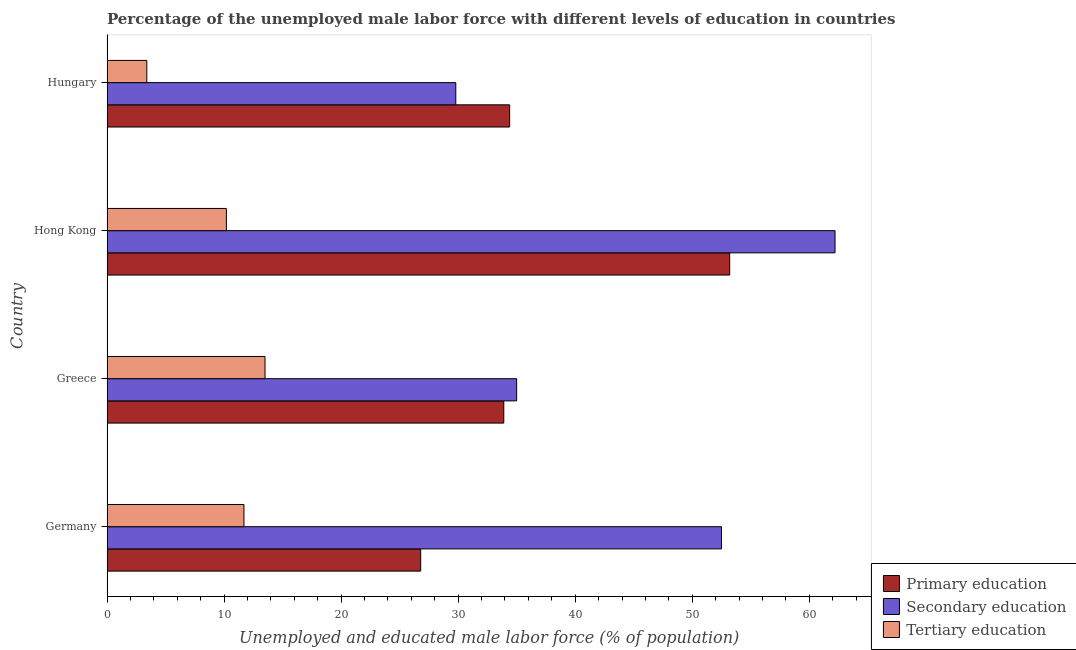How many groups of bars are there?
Your answer should be compact. 4. Are the number of bars on each tick of the Y-axis equal?
Your answer should be compact. Yes. How many bars are there on the 1st tick from the top?
Ensure brevity in your answer.  3. What is the label of the 2nd group of bars from the top?
Your answer should be compact. Hong Kong. In how many cases, is the number of bars for a given country not equal to the number of legend labels?
Keep it short and to the point. 0. What is the percentage of male labor force who received primary education in Germany?
Give a very brief answer. 26.8. Across all countries, what is the maximum percentage of male labor force who received secondary education?
Give a very brief answer. 62.2. Across all countries, what is the minimum percentage of male labor force who received secondary education?
Give a very brief answer. 29.8. In which country was the percentage of male labor force who received primary education maximum?
Make the answer very short. Hong Kong. In which country was the percentage of male labor force who received tertiary education minimum?
Your answer should be very brief. Hungary. What is the total percentage of male labor force who received primary education in the graph?
Your response must be concise. 148.3. What is the difference between the percentage of male labor force who received tertiary education in Germany and that in Hong Kong?
Keep it short and to the point. 1.5. What is the difference between the percentage of male labor force who received tertiary education in Hungary and the percentage of male labor force who received primary education in Hong Kong?
Provide a short and direct response. -49.8. What is the average percentage of male labor force who received tertiary education per country?
Offer a very short reply. 9.7. What is the difference between the percentage of male labor force who received tertiary education and percentage of male labor force who received primary education in Hong Kong?
Give a very brief answer. -43. In how many countries, is the percentage of male labor force who received tertiary education greater than 50 %?
Provide a succinct answer. 0. What is the ratio of the percentage of male labor force who received tertiary education in Germany to that in Greece?
Your answer should be very brief. 0.87. What is the difference between the highest and the second highest percentage of male labor force who received secondary education?
Provide a succinct answer. 9.7. What is the difference between the highest and the lowest percentage of male labor force who received tertiary education?
Offer a very short reply. 10.1. What does the 1st bar from the top in Greece represents?
Your answer should be very brief. Tertiary education. What does the 2nd bar from the bottom in Greece represents?
Offer a very short reply. Secondary education. Are all the bars in the graph horizontal?
Provide a short and direct response. Yes. Does the graph contain grids?
Keep it short and to the point. No. Where does the legend appear in the graph?
Ensure brevity in your answer.  Bottom right. How many legend labels are there?
Provide a succinct answer. 3. How are the legend labels stacked?
Give a very brief answer. Vertical. What is the title of the graph?
Provide a short and direct response. Percentage of the unemployed male labor force with different levels of education in countries. What is the label or title of the X-axis?
Provide a succinct answer. Unemployed and educated male labor force (% of population). What is the Unemployed and educated male labor force (% of population) of Primary education in Germany?
Your answer should be compact. 26.8. What is the Unemployed and educated male labor force (% of population) of Secondary education in Germany?
Provide a succinct answer. 52.5. What is the Unemployed and educated male labor force (% of population) of Tertiary education in Germany?
Provide a short and direct response. 11.7. What is the Unemployed and educated male labor force (% of population) in Primary education in Greece?
Your answer should be compact. 33.9. What is the Unemployed and educated male labor force (% of population) of Secondary education in Greece?
Provide a succinct answer. 35. What is the Unemployed and educated male labor force (% of population) of Primary education in Hong Kong?
Provide a short and direct response. 53.2. What is the Unemployed and educated male labor force (% of population) in Secondary education in Hong Kong?
Give a very brief answer. 62.2. What is the Unemployed and educated male labor force (% of population) of Tertiary education in Hong Kong?
Your answer should be compact. 10.2. What is the Unemployed and educated male labor force (% of population) of Primary education in Hungary?
Your response must be concise. 34.4. What is the Unemployed and educated male labor force (% of population) of Secondary education in Hungary?
Your answer should be compact. 29.8. What is the Unemployed and educated male labor force (% of population) of Tertiary education in Hungary?
Your answer should be very brief. 3.4. Across all countries, what is the maximum Unemployed and educated male labor force (% of population) of Primary education?
Provide a succinct answer. 53.2. Across all countries, what is the maximum Unemployed and educated male labor force (% of population) in Secondary education?
Provide a succinct answer. 62.2. Across all countries, what is the maximum Unemployed and educated male labor force (% of population) of Tertiary education?
Give a very brief answer. 13.5. Across all countries, what is the minimum Unemployed and educated male labor force (% of population) in Primary education?
Offer a terse response. 26.8. Across all countries, what is the minimum Unemployed and educated male labor force (% of population) of Secondary education?
Your response must be concise. 29.8. Across all countries, what is the minimum Unemployed and educated male labor force (% of population) in Tertiary education?
Your response must be concise. 3.4. What is the total Unemployed and educated male labor force (% of population) of Primary education in the graph?
Ensure brevity in your answer.  148.3. What is the total Unemployed and educated male labor force (% of population) in Secondary education in the graph?
Give a very brief answer. 179.5. What is the total Unemployed and educated male labor force (% of population) in Tertiary education in the graph?
Your answer should be compact. 38.8. What is the difference between the Unemployed and educated male labor force (% of population) of Secondary education in Germany and that in Greece?
Your answer should be compact. 17.5. What is the difference between the Unemployed and educated male labor force (% of population) in Primary education in Germany and that in Hong Kong?
Your answer should be very brief. -26.4. What is the difference between the Unemployed and educated male labor force (% of population) in Secondary education in Germany and that in Hungary?
Your answer should be very brief. 22.7. What is the difference between the Unemployed and educated male labor force (% of population) of Tertiary education in Germany and that in Hungary?
Offer a very short reply. 8.3. What is the difference between the Unemployed and educated male labor force (% of population) of Primary education in Greece and that in Hong Kong?
Your answer should be compact. -19.3. What is the difference between the Unemployed and educated male labor force (% of population) in Secondary education in Greece and that in Hong Kong?
Provide a succinct answer. -27.2. What is the difference between the Unemployed and educated male labor force (% of population) in Secondary education in Greece and that in Hungary?
Your answer should be compact. 5.2. What is the difference between the Unemployed and educated male labor force (% of population) of Tertiary education in Greece and that in Hungary?
Ensure brevity in your answer.  10.1. What is the difference between the Unemployed and educated male labor force (% of population) in Secondary education in Hong Kong and that in Hungary?
Ensure brevity in your answer.  32.4. What is the difference between the Unemployed and educated male labor force (% of population) of Primary education in Germany and the Unemployed and educated male labor force (% of population) of Secondary education in Greece?
Give a very brief answer. -8.2. What is the difference between the Unemployed and educated male labor force (% of population) in Primary education in Germany and the Unemployed and educated male labor force (% of population) in Tertiary education in Greece?
Keep it short and to the point. 13.3. What is the difference between the Unemployed and educated male labor force (% of population) in Primary education in Germany and the Unemployed and educated male labor force (% of population) in Secondary education in Hong Kong?
Offer a very short reply. -35.4. What is the difference between the Unemployed and educated male labor force (% of population) in Primary education in Germany and the Unemployed and educated male labor force (% of population) in Tertiary education in Hong Kong?
Your answer should be compact. 16.6. What is the difference between the Unemployed and educated male labor force (% of population) in Secondary education in Germany and the Unemployed and educated male labor force (% of population) in Tertiary education in Hong Kong?
Provide a succinct answer. 42.3. What is the difference between the Unemployed and educated male labor force (% of population) in Primary education in Germany and the Unemployed and educated male labor force (% of population) in Secondary education in Hungary?
Offer a very short reply. -3. What is the difference between the Unemployed and educated male labor force (% of population) in Primary education in Germany and the Unemployed and educated male labor force (% of population) in Tertiary education in Hungary?
Give a very brief answer. 23.4. What is the difference between the Unemployed and educated male labor force (% of population) of Secondary education in Germany and the Unemployed and educated male labor force (% of population) of Tertiary education in Hungary?
Offer a very short reply. 49.1. What is the difference between the Unemployed and educated male labor force (% of population) of Primary education in Greece and the Unemployed and educated male labor force (% of population) of Secondary education in Hong Kong?
Your answer should be very brief. -28.3. What is the difference between the Unemployed and educated male labor force (% of population) of Primary education in Greece and the Unemployed and educated male labor force (% of population) of Tertiary education in Hong Kong?
Offer a terse response. 23.7. What is the difference between the Unemployed and educated male labor force (% of population) of Secondary education in Greece and the Unemployed and educated male labor force (% of population) of Tertiary education in Hong Kong?
Offer a very short reply. 24.8. What is the difference between the Unemployed and educated male labor force (% of population) in Primary education in Greece and the Unemployed and educated male labor force (% of population) in Tertiary education in Hungary?
Offer a very short reply. 30.5. What is the difference between the Unemployed and educated male labor force (% of population) in Secondary education in Greece and the Unemployed and educated male labor force (% of population) in Tertiary education in Hungary?
Ensure brevity in your answer.  31.6. What is the difference between the Unemployed and educated male labor force (% of population) of Primary education in Hong Kong and the Unemployed and educated male labor force (% of population) of Secondary education in Hungary?
Keep it short and to the point. 23.4. What is the difference between the Unemployed and educated male labor force (% of population) in Primary education in Hong Kong and the Unemployed and educated male labor force (% of population) in Tertiary education in Hungary?
Ensure brevity in your answer.  49.8. What is the difference between the Unemployed and educated male labor force (% of population) of Secondary education in Hong Kong and the Unemployed and educated male labor force (% of population) of Tertiary education in Hungary?
Your answer should be very brief. 58.8. What is the average Unemployed and educated male labor force (% of population) in Primary education per country?
Your response must be concise. 37.08. What is the average Unemployed and educated male labor force (% of population) of Secondary education per country?
Keep it short and to the point. 44.88. What is the difference between the Unemployed and educated male labor force (% of population) in Primary education and Unemployed and educated male labor force (% of population) in Secondary education in Germany?
Your response must be concise. -25.7. What is the difference between the Unemployed and educated male labor force (% of population) of Primary education and Unemployed and educated male labor force (% of population) of Tertiary education in Germany?
Your response must be concise. 15.1. What is the difference between the Unemployed and educated male labor force (% of population) in Secondary education and Unemployed and educated male labor force (% of population) in Tertiary education in Germany?
Ensure brevity in your answer.  40.8. What is the difference between the Unemployed and educated male labor force (% of population) in Primary education and Unemployed and educated male labor force (% of population) in Tertiary education in Greece?
Offer a very short reply. 20.4. What is the difference between the Unemployed and educated male labor force (% of population) in Primary education and Unemployed and educated male labor force (% of population) in Secondary education in Hong Kong?
Offer a very short reply. -9. What is the difference between the Unemployed and educated male labor force (% of population) of Secondary education and Unemployed and educated male labor force (% of population) of Tertiary education in Hong Kong?
Make the answer very short. 52. What is the difference between the Unemployed and educated male labor force (% of population) in Secondary education and Unemployed and educated male labor force (% of population) in Tertiary education in Hungary?
Offer a very short reply. 26.4. What is the ratio of the Unemployed and educated male labor force (% of population) in Primary education in Germany to that in Greece?
Offer a terse response. 0.79. What is the ratio of the Unemployed and educated male labor force (% of population) in Tertiary education in Germany to that in Greece?
Make the answer very short. 0.87. What is the ratio of the Unemployed and educated male labor force (% of population) of Primary education in Germany to that in Hong Kong?
Give a very brief answer. 0.5. What is the ratio of the Unemployed and educated male labor force (% of population) in Secondary education in Germany to that in Hong Kong?
Your answer should be compact. 0.84. What is the ratio of the Unemployed and educated male labor force (% of population) in Tertiary education in Germany to that in Hong Kong?
Give a very brief answer. 1.15. What is the ratio of the Unemployed and educated male labor force (% of population) of Primary education in Germany to that in Hungary?
Provide a succinct answer. 0.78. What is the ratio of the Unemployed and educated male labor force (% of population) in Secondary education in Germany to that in Hungary?
Keep it short and to the point. 1.76. What is the ratio of the Unemployed and educated male labor force (% of population) of Tertiary education in Germany to that in Hungary?
Provide a short and direct response. 3.44. What is the ratio of the Unemployed and educated male labor force (% of population) of Primary education in Greece to that in Hong Kong?
Keep it short and to the point. 0.64. What is the ratio of the Unemployed and educated male labor force (% of population) of Secondary education in Greece to that in Hong Kong?
Offer a terse response. 0.56. What is the ratio of the Unemployed and educated male labor force (% of population) in Tertiary education in Greece to that in Hong Kong?
Offer a very short reply. 1.32. What is the ratio of the Unemployed and educated male labor force (% of population) in Primary education in Greece to that in Hungary?
Your answer should be very brief. 0.99. What is the ratio of the Unemployed and educated male labor force (% of population) of Secondary education in Greece to that in Hungary?
Offer a very short reply. 1.17. What is the ratio of the Unemployed and educated male labor force (% of population) in Tertiary education in Greece to that in Hungary?
Provide a succinct answer. 3.97. What is the ratio of the Unemployed and educated male labor force (% of population) of Primary education in Hong Kong to that in Hungary?
Keep it short and to the point. 1.55. What is the ratio of the Unemployed and educated male labor force (% of population) of Secondary education in Hong Kong to that in Hungary?
Ensure brevity in your answer.  2.09. What is the difference between the highest and the lowest Unemployed and educated male labor force (% of population) of Primary education?
Keep it short and to the point. 26.4. What is the difference between the highest and the lowest Unemployed and educated male labor force (% of population) of Secondary education?
Offer a terse response. 32.4. 